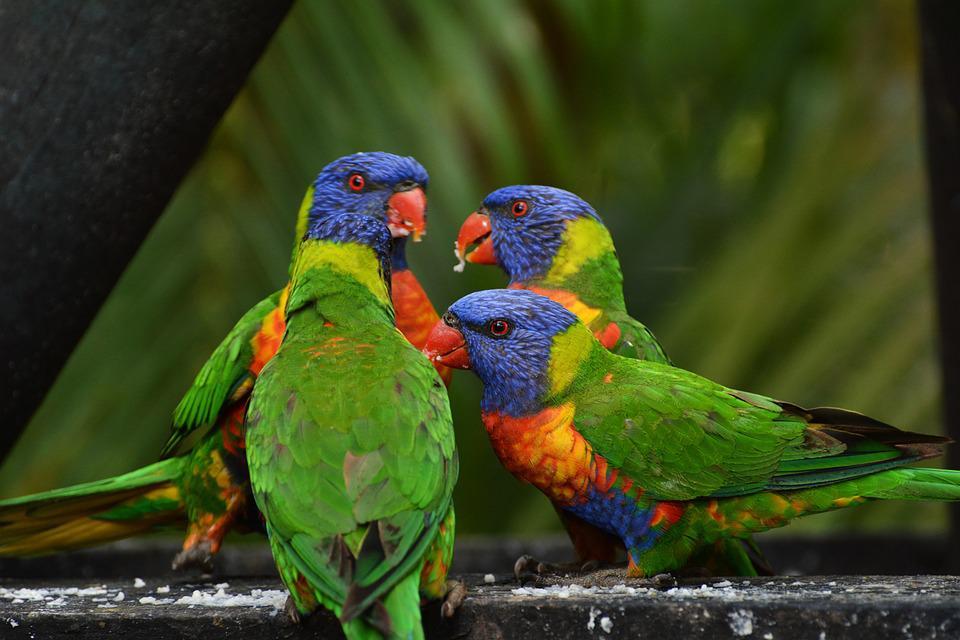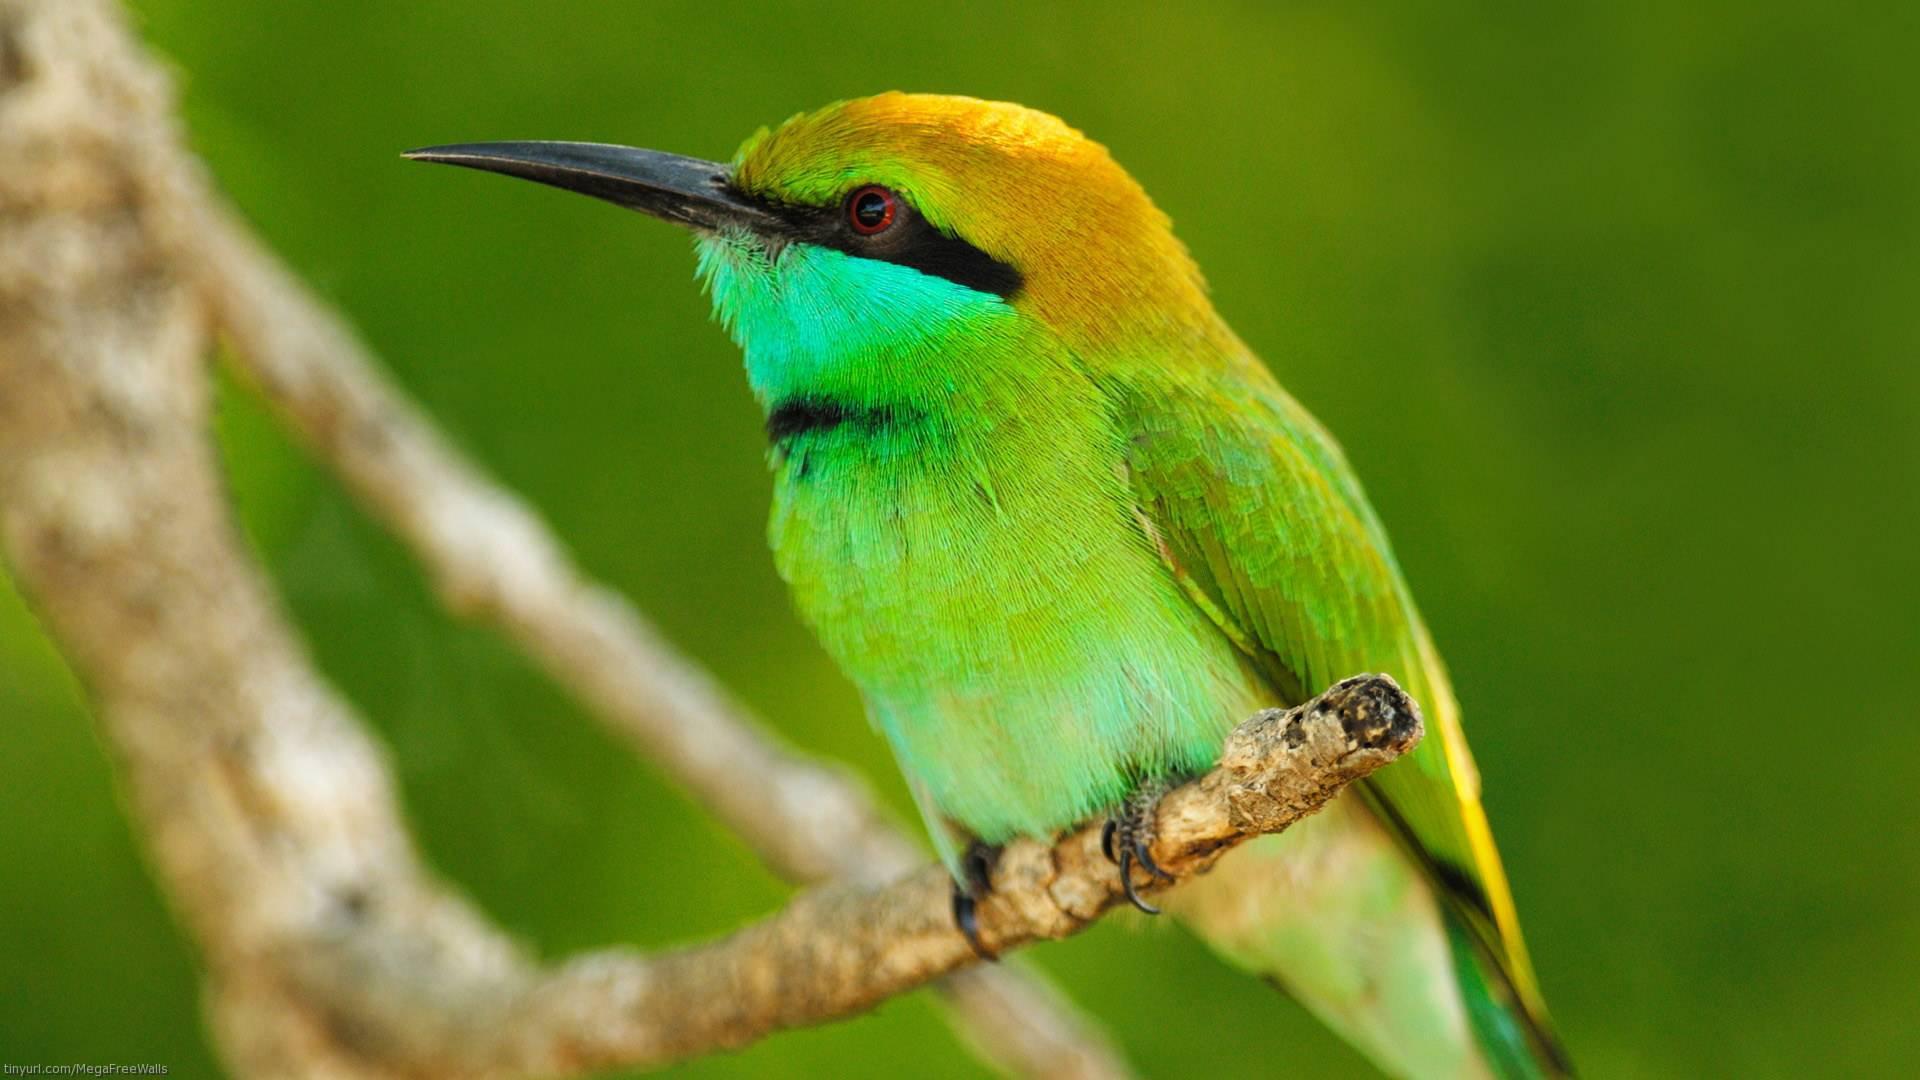The first image is the image on the left, the second image is the image on the right. Evaluate the accuracy of this statement regarding the images: "There are three birds". Is it true? Answer yes or no. Yes. 